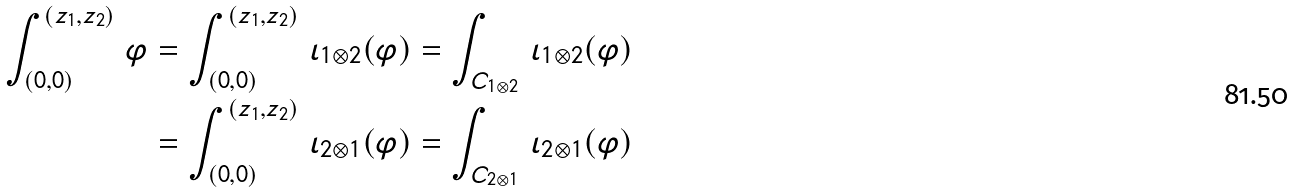<formula> <loc_0><loc_0><loc_500><loc_500>\int _ { ( 0 , 0 ) } ^ { ( z _ { 1 } , z _ { 2 } ) } \, \varphi & = \int _ { ( 0 , 0 ) } ^ { ( z _ { 1 } , z _ { 2 } ) } \, \iota _ { 1 \otimes 2 } ( \varphi ) = \int _ { C _ { 1 \otimes 2 } } \, \iota _ { 1 \otimes 2 } ( \varphi ) \\ & = \int _ { ( 0 , 0 ) } ^ { ( z _ { 1 } , z _ { 2 } ) } \, \iota _ { 2 \otimes 1 } ( \varphi ) = \int _ { C _ { 2 \otimes 1 } } \, \iota _ { 2 \otimes 1 } ( \varphi )</formula> 